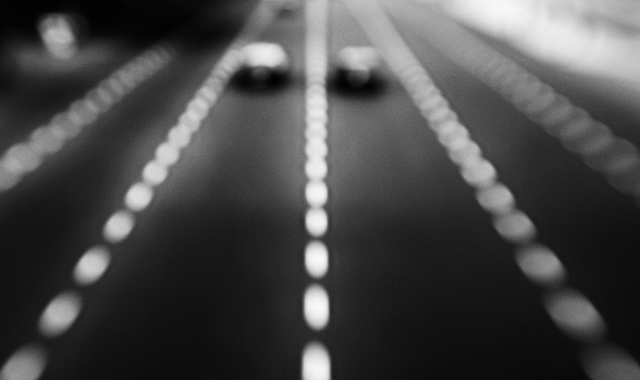What kind of atmosphere or mood does the blurred imagery in this photo evoke? The blurred quality of the image gives it an ethereal and dynamic feel, suggesting movement and a fleeting moment in time. It could evoke feelings of haste, the chaos of life in motion, or even a dream-like state where details are obscured and the overall impression is more important than specific elements. 